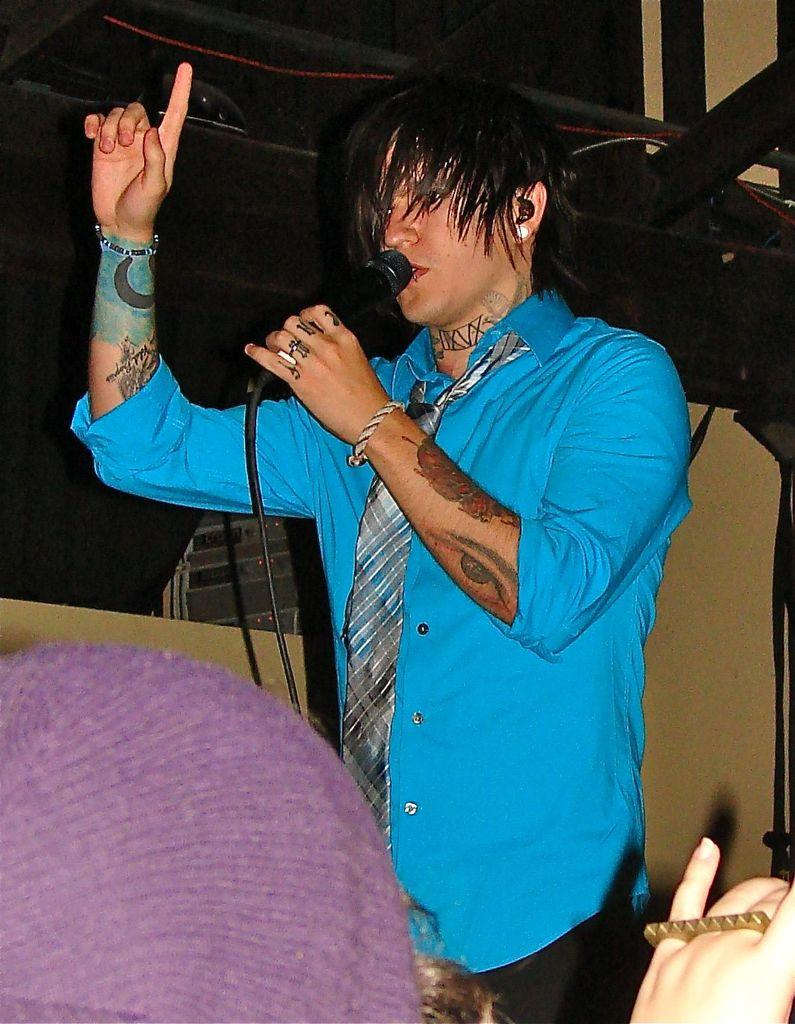What is the position of the person at the bottom of the image? There is a person sitting at the bottom of the image. What is the position of the other person in the image? There is a person standing in the middle of the image. What is the standing person holding? The standing person is holding a microphone. What can be seen behind the standing person? There is a wall behind the person. What type of jelly can be seen on the wall in the image? There is no jelly present on the wall or in the image. What effect does the microphone have on the person holding it? The image does not show any effect on the person holding the microphone; it only shows them holding it. 